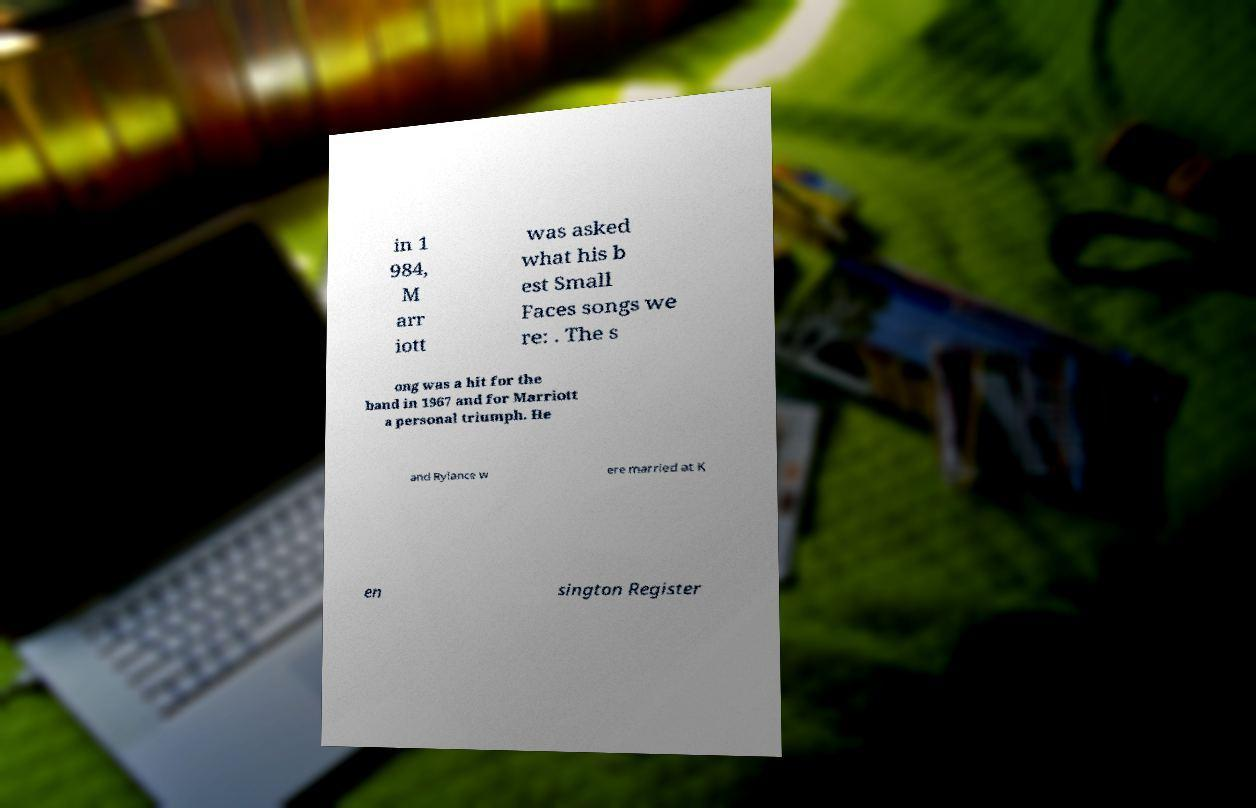Please identify and transcribe the text found in this image. in 1 984, M arr iott was asked what his b est Small Faces songs we re: . The s ong was a hit for the band in 1967 and for Marriott a personal triumph. He and Rylance w ere married at K en sington Register 